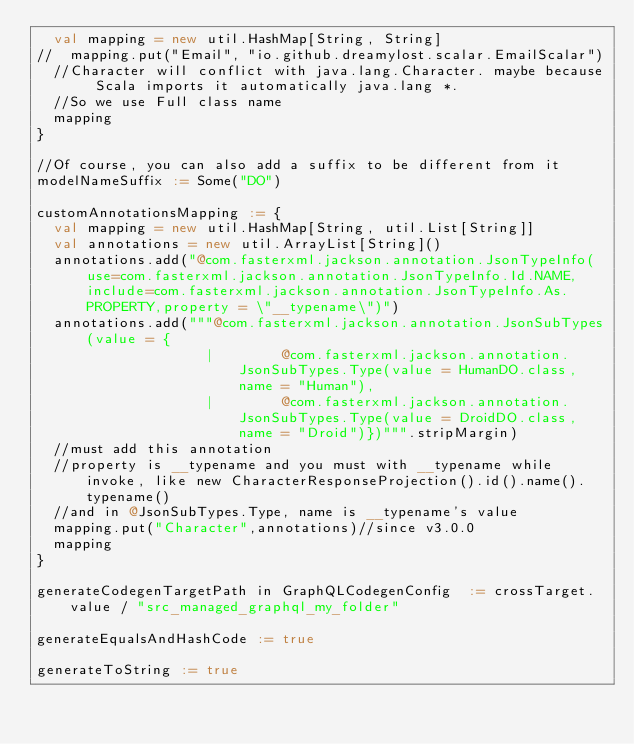Convert code to text. <code><loc_0><loc_0><loc_500><loc_500><_Scala_>  val mapping = new util.HashMap[String, String]
//  mapping.put("Email", "io.github.dreamylost.scalar.EmailScalar")
  //Character will conflict with java.lang.Character. maybe because Scala imports it automatically java.lang *.
  //So we use Full class name
  mapping
}

//Of course, you can also add a suffix to be different from it
modelNameSuffix := Some("DO")

customAnnotationsMapping := {
  val mapping = new util.HashMap[String, util.List[String]]
  val annotations = new util.ArrayList[String]()
  annotations.add("@com.fasterxml.jackson.annotation.JsonTypeInfo(use=com.fasterxml.jackson.annotation.JsonTypeInfo.Id.NAME, include=com.fasterxml.jackson.annotation.JsonTypeInfo.As.PROPERTY,property = \"__typename\")")
  annotations.add("""@com.fasterxml.jackson.annotation.JsonSubTypes(value = {
                    |        @com.fasterxml.jackson.annotation.JsonSubTypes.Type(value = HumanDO.class, name = "Human"),
                    |        @com.fasterxml.jackson.annotation.JsonSubTypes.Type(value = DroidDO.class, name = "Droid")})""".stripMargin)
  //must add this annotation
  //property is __typename and you must with __typename while invoke, like new CharacterResponseProjection().id().name().typename()
  //and in @JsonSubTypes.Type, name is __typename's value
  mapping.put("Character",annotations)//since v3.0.0
  mapping
}

generateCodegenTargetPath in GraphQLCodegenConfig  := crossTarget.value / "src_managed_graphql_my_folder"

generateEqualsAndHashCode := true

generateToString := true</code> 